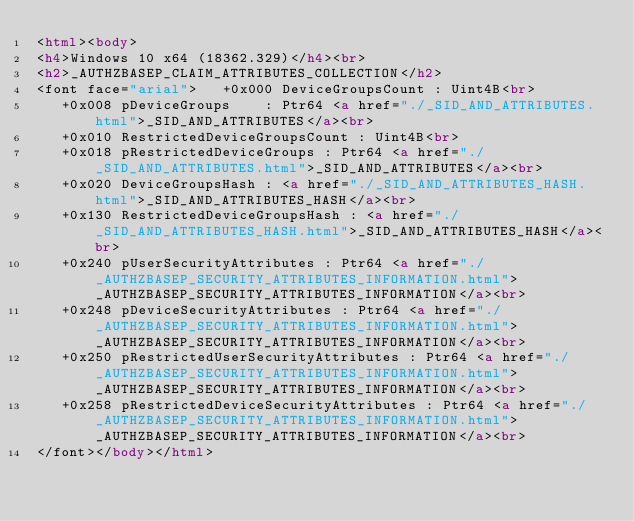Convert code to text. <code><loc_0><loc_0><loc_500><loc_500><_HTML_><html><body>
<h4>Windows 10 x64 (18362.329)</h4><br>
<h2>_AUTHZBASEP_CLAIM_ATTRIBUTES_COLLECTION</h2>
<font face="arial">   +0x000 DeviceGroupsCount : Uint4B<br>
   +0x008 pDeviceGroups    : Ptr64 <a href="./_SID_AND_ATTRIBUTES.html">_SID_AND_ATTRIBUTES</a><br>
   +0x010 RestrictedDeviceGroupsCount : Uint4B<br>
   +0x018 pRestrictedDeviceGroups : Ptr64 <a href="./_SID_AND_ATTRIBUTES.html">_SID_AND_ATTRIBUTES</a><br>
   +0x020 DeviceGroupsHash : <a href="./_SID_AND_ATTRIBUTES_HASH.html">_SID_AND_ATTRIBUTES_HASH</a><br>
   +0x130 RestrictedDeviceGroupsHash : <a href="./_SID_AND_ATTRIBUTES_HASH.html">_SID_AND_ATTRIBUTES_HASH</a><br>
   +0x240 pUserSecurityAttributes : Ptr64 <a href="./_AUTHZBASEP_SECURITY_ATTRIBUTES_INFORMATION.html">_AUTHZBASEP_SECURITY_ATTRIBUTES_INFORMATION</a><br>
   +0x248 pDeviceSecurityAttributes : Ptr64 <a href="./_AUTHZBASEP_SECURITY_ATTRIBUTES_INFORMATION.html">_AUTHZBASEP_SECURITY_ATTRIBUTES_INFORMATION</a><br>
   +0x250 pRestrictedUserSecurityAttributes : Ptr64 <a href="./_AUTHZBASEP_SECURITY_ATTRIBUTES_INFORMATION.html">_AUTHZBASEP_SECURITY_ATTRIBUTES_INFORMATION</a><br>
   +0x258 pRestrictedDeviceSecurityAttributes : Ptr64 <a href="./_AUTHZBASEP_SECURITY_ATTRIBUTES_INFORMATION.html">_AUTHZBASEP_SECURITY_ATTRIBUTES_INFORMATION</a><br>
</font></body></html></code> 